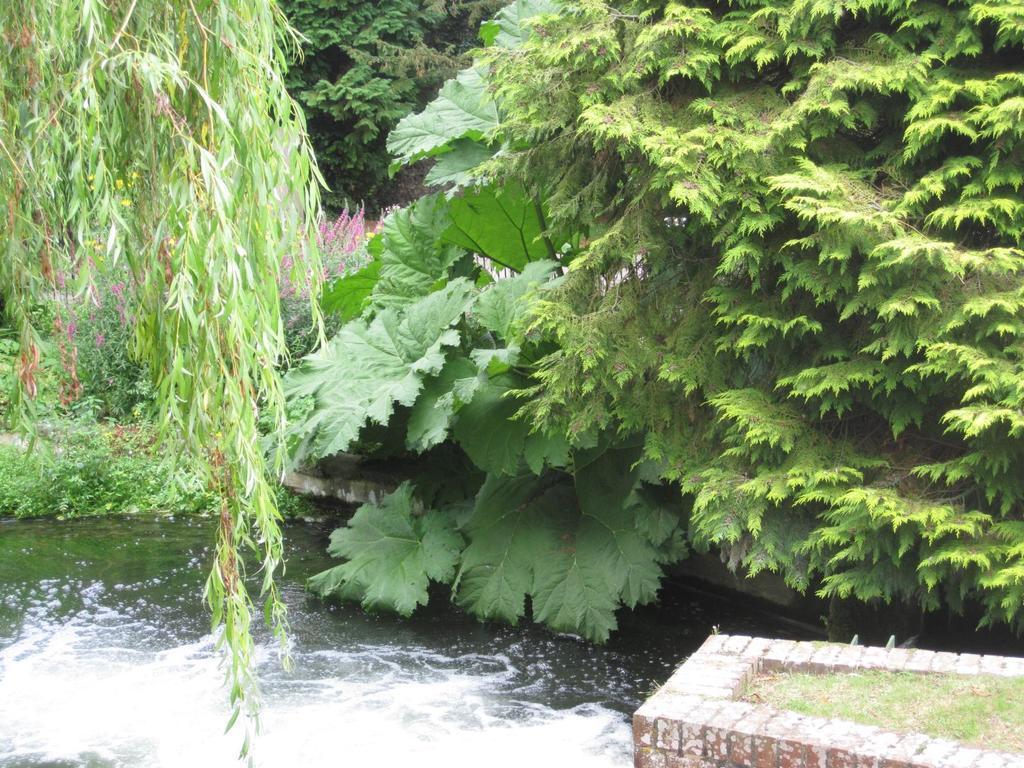In one or two sentences, can you explain what this image depicts? In the image in the center we can see trees,plants,grass,water and brick wall. 